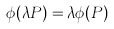Convert formula to latex. <formula><loc_0><loc_0><loc_500><loc_500>\phi ( \lambda P ) = \lambda \phi ( P )</formula> 